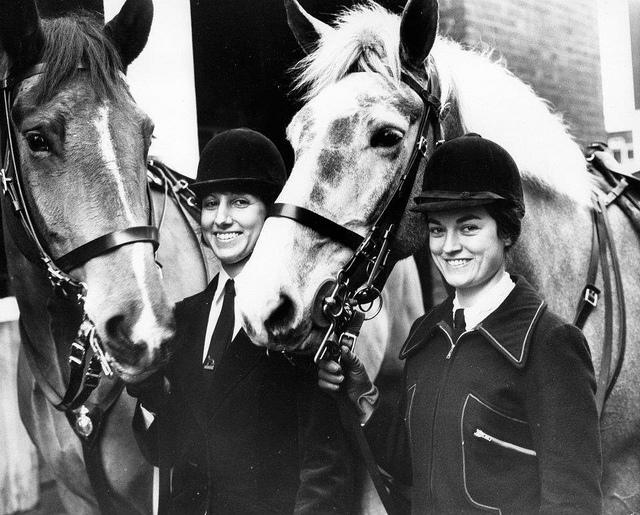How many women?
Be succinct. 2. Which woman has the lighter horse?
Be succinct. Right. What kind of hat are the women wearing?
Concise answer only. Riding. What is covering the horses' eyes?
Short answer required. Nothing. 